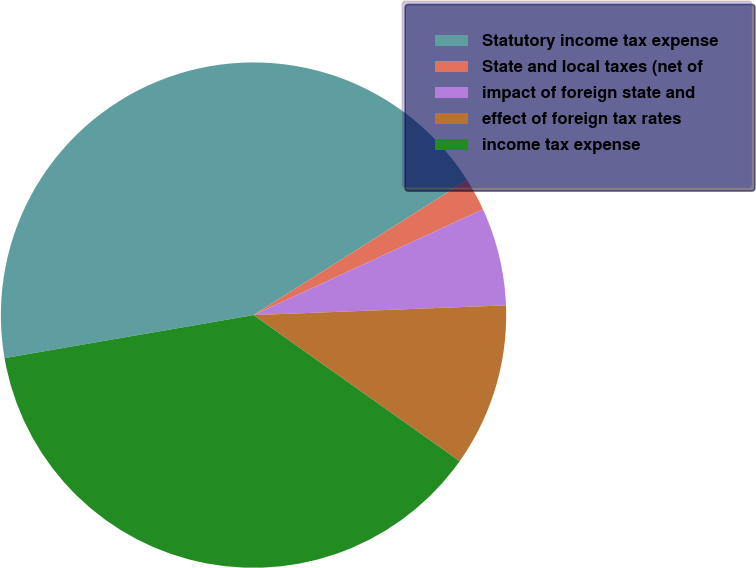<chart> <loc_0><loc_0><loc_500><loc_500><pie_chart><fcel>Statutory income tax expense<fcel>State and local taxes (net of<fcel>impact of foreign state and<fcel>effect of foreign tax rates<fcel>income tax expense<nl><fcel>43.75%<fcel>2.1%<fcel>6.26%<fcel>10.43%<fcel>37.46%<nl></chart> 